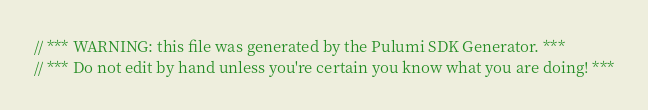Convert code to text. <code><loc_0><loc_0><loc_500><loc_500><_C#_>// *** WARNING: this file was generated by the Pulumi SDK Generator. ***
// *** Do not edit by hand unless you're certain you know what you are doing! ***
</code> 